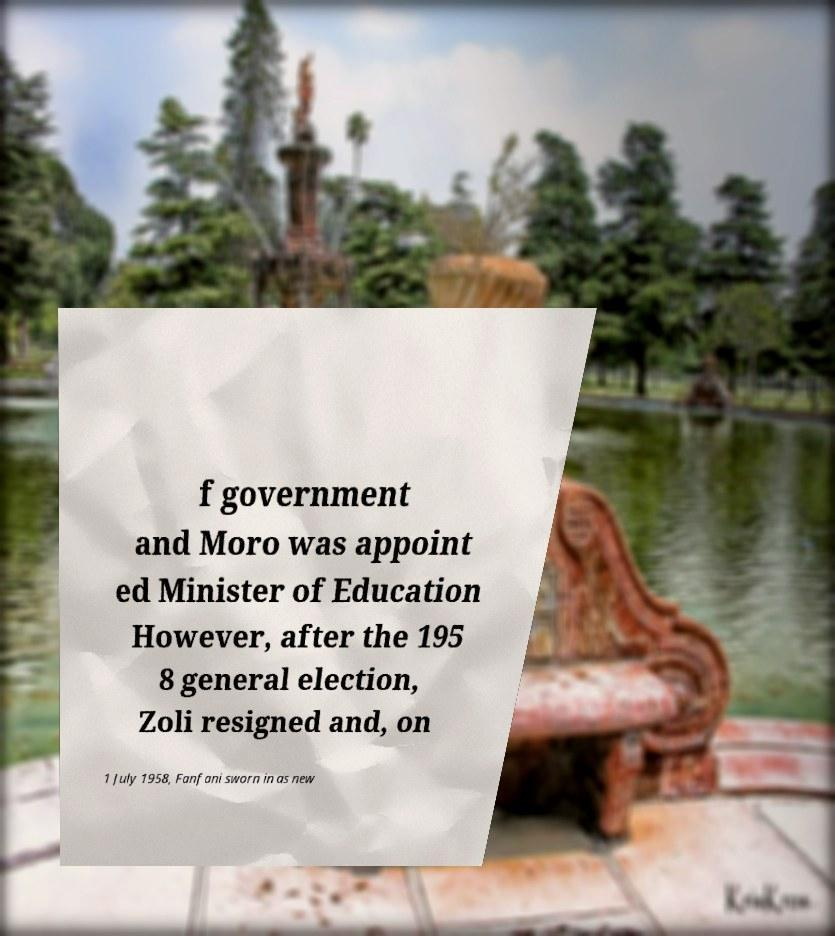For documentation purposes, I need the text within this image transcribed. Could you provide that? f government and Moro was appoint ed Minister of Education However, after the 195 8 general election, Zoli resigned and, on 1 July 1958, Fanfani sworn in as new 